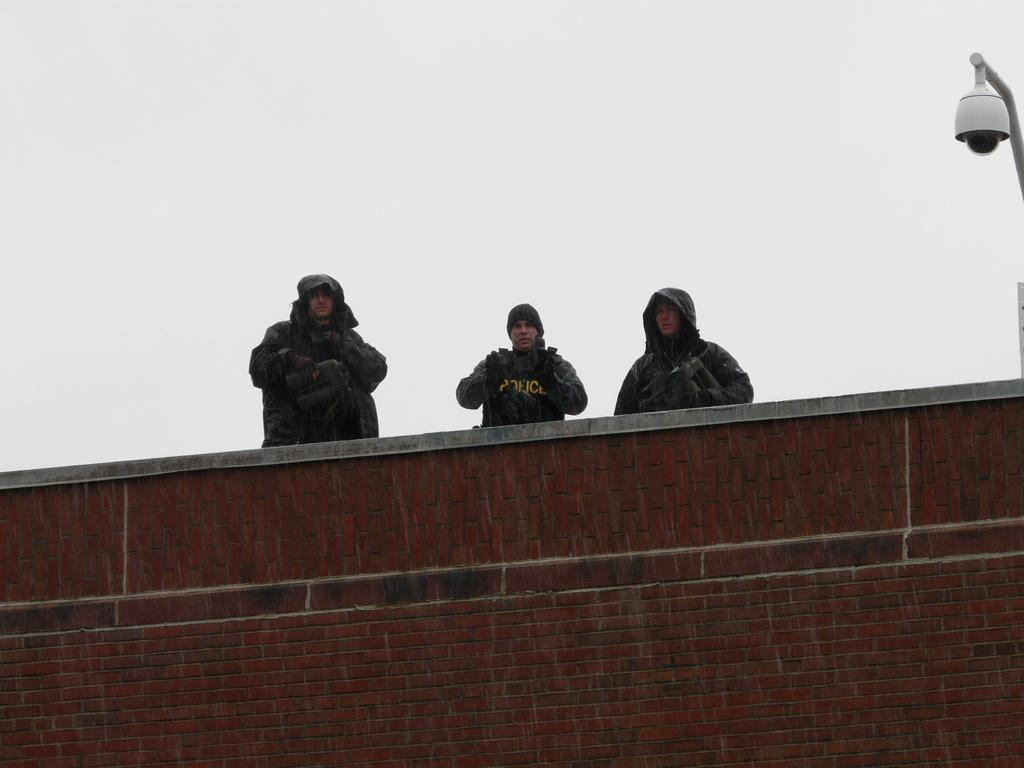What type of structure is visible in the image? There is a brick wall in the image. What are the people in the image doing? Three people are standing on top of the wall. Where is the light located in the image? There is a light at the right side of the image. What type of mark can be seen on the wall in the image? There is no mark visible on the wall in the image. How does the temper of the people on the wall affect the situation in the image? There is no information about the temper of the people in the image, so it cannot be determined how it affects the situation. 